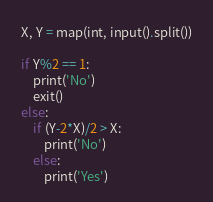Convert code to text. <code><loc_0><loc_0><loc_500><loc_500><_Python_>X, Y = map(int, input().split())

if Y%2 == 1:
    print('No')
    exit()
else:
    if (Y-2*X)/2 > X:
        print('No')
    else:
        print('Yes')
</code> 